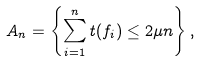<formula> <loc_0><loc_0><loc_500><loc_500>A _ { n } = \left \{ \sum _ { i = 1 } ^ { n } t ( f _ { i } ) \leq 2 \mu n \right \} ,</formula> 